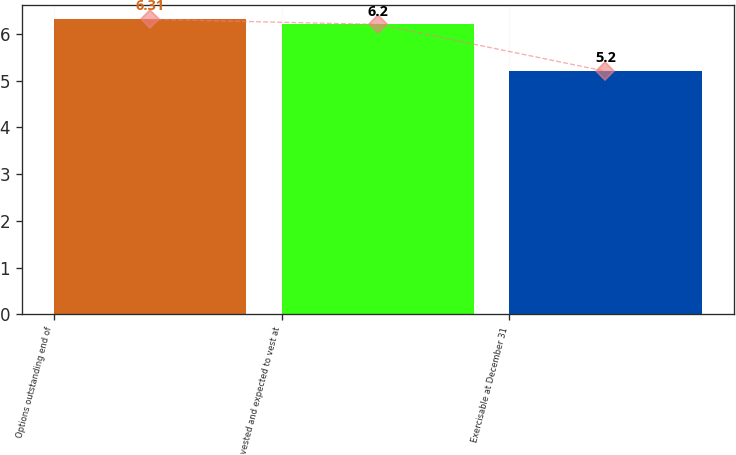Convert chart. <chart><loc_0><loc_0><loc_500><loc_500><bar_chart><fcel>Options outstanding end of<fcel>vested and expected to vest at<fcel>Exercisable at December 31<nl><fcel>6.31<fcel>6.2<fcel>5.2<nl></chart> 